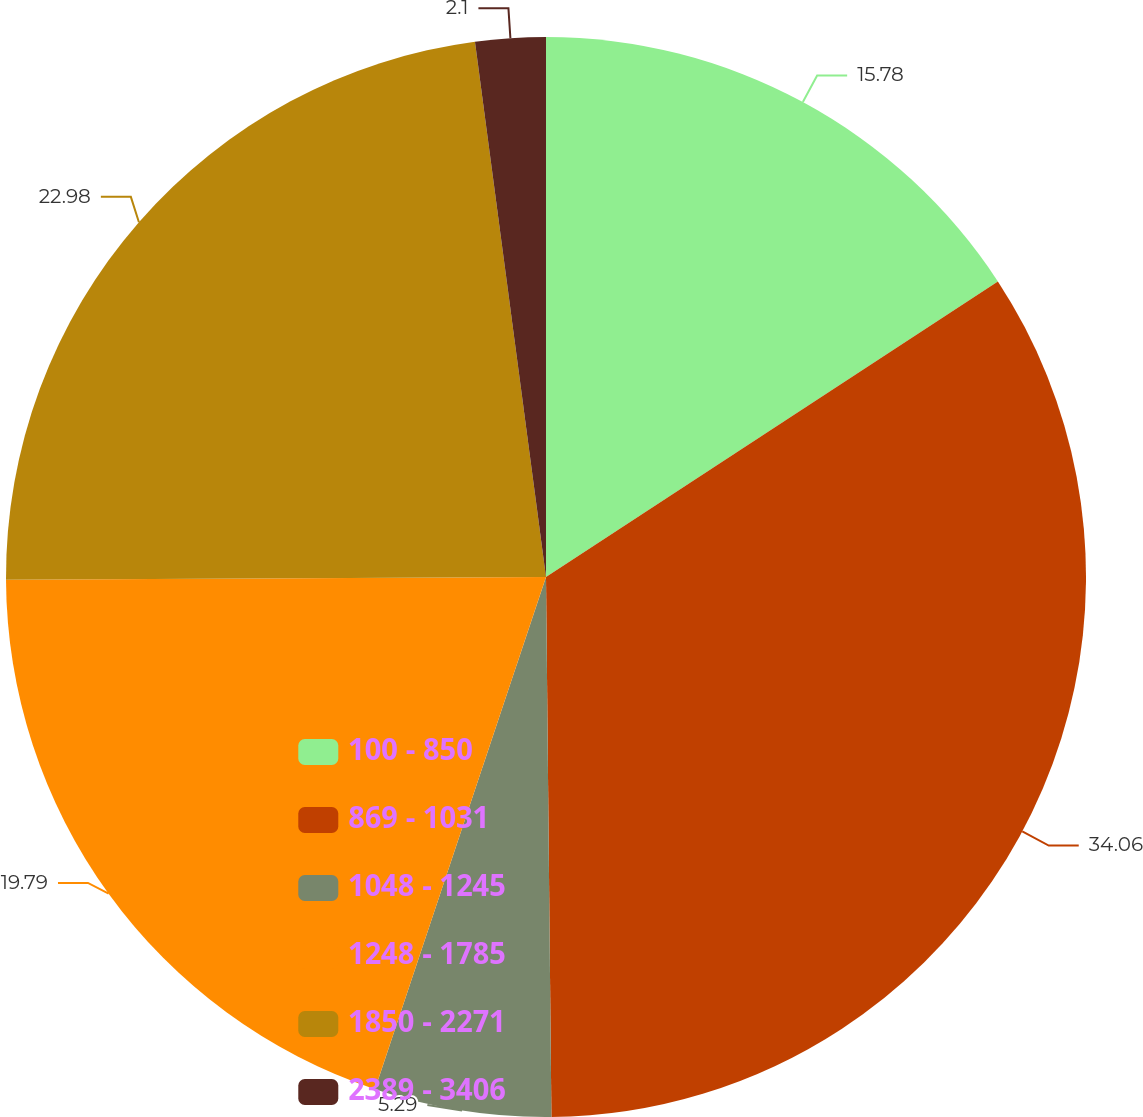Convert chart. <chart><loc_0><loc_0><loc_500><loc_500><pie_chart><fcel>100 - 850<fcel>869 - 1031<fcel>1048 - 1245<fcel>1248 - 1785<fcel>1850 - 2271<fcel>2389 - 3406<nl><fcel>15.78%<fcel>34.06%<fcel>5.29%<fcel>19.79%<fcel>22.98%<fcel>2.1%<nl></chart> 